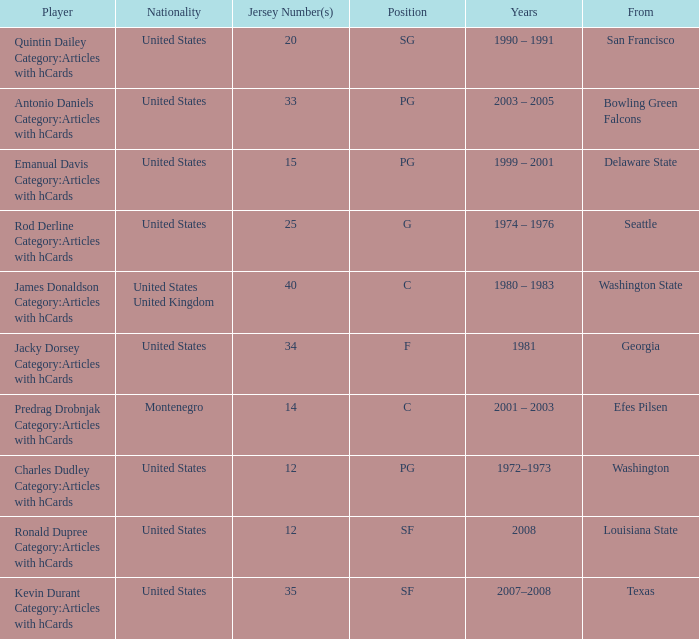What is the lowest jersey number of a player from louisiana state? 12.0. 